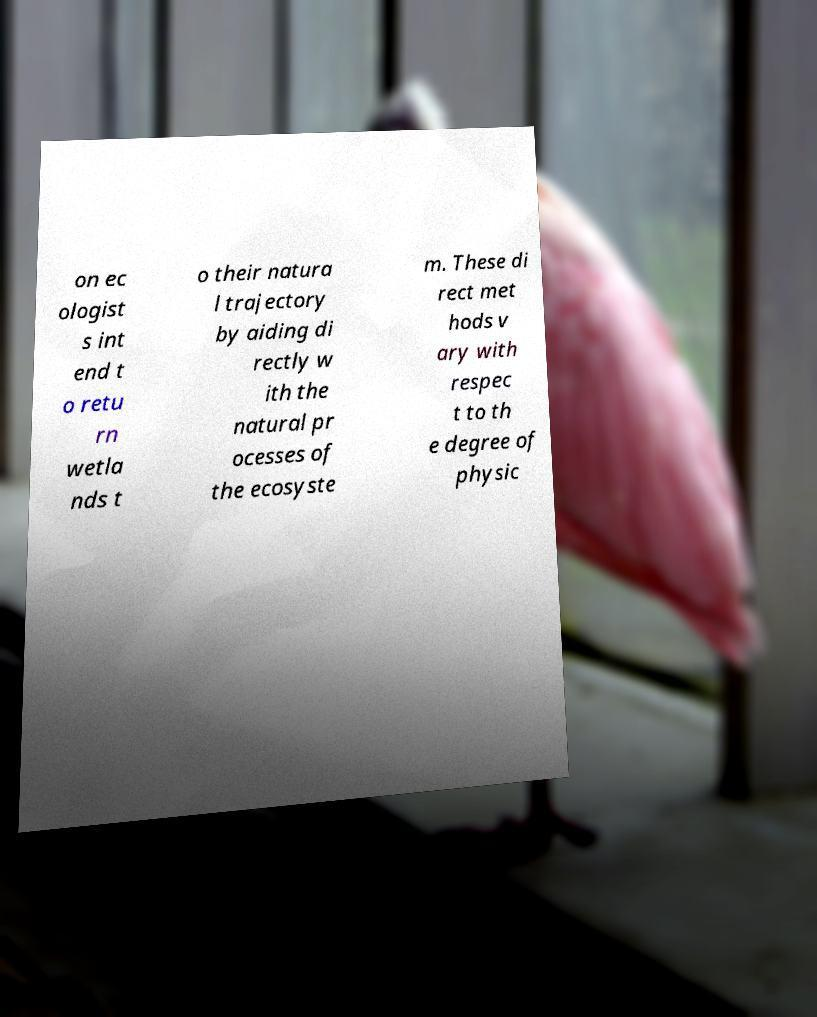Could you assist in decoding the text presented in this image and type it out clearly? on ec ologist s int end t o retu rn wetla nds t o their natura l trajectory by aiding di rectly w ith the natural pr ocesses of the ecosyste m. These di rect met hods v ary with respec t to th e degree of physic 